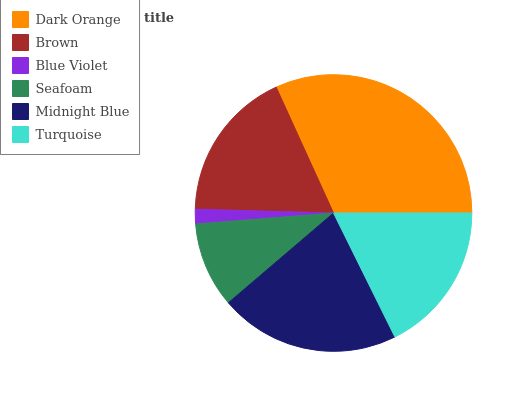Is Blue Violet the minimum?
Answer yes or no. Yes. Is Dark Orange the maximum?
Answer yes or no. Yes. Is Brown the minimum?
Answer yes or no. No. Is Brown the maximum?
Answer yes or no. No. Is Dark Orange greater than Brown?
Answer yes or no. Yes. Is Brown less than Dark Orange?
Answer yes or no. Yes. Is Brown greater than Dark Orange?
Answer yes or no. No. Is Dark Orange less than Brown?
Answer yes or no. No. Is Brown the high median?
Answer yes or no. Yes. Is Turquoise the low median?
Answer yes or no. Yes. Is Midnight Blue the high median?
Answer yes or no. No. Is Midnight Blue the low median?
Answer yes or no. No. 